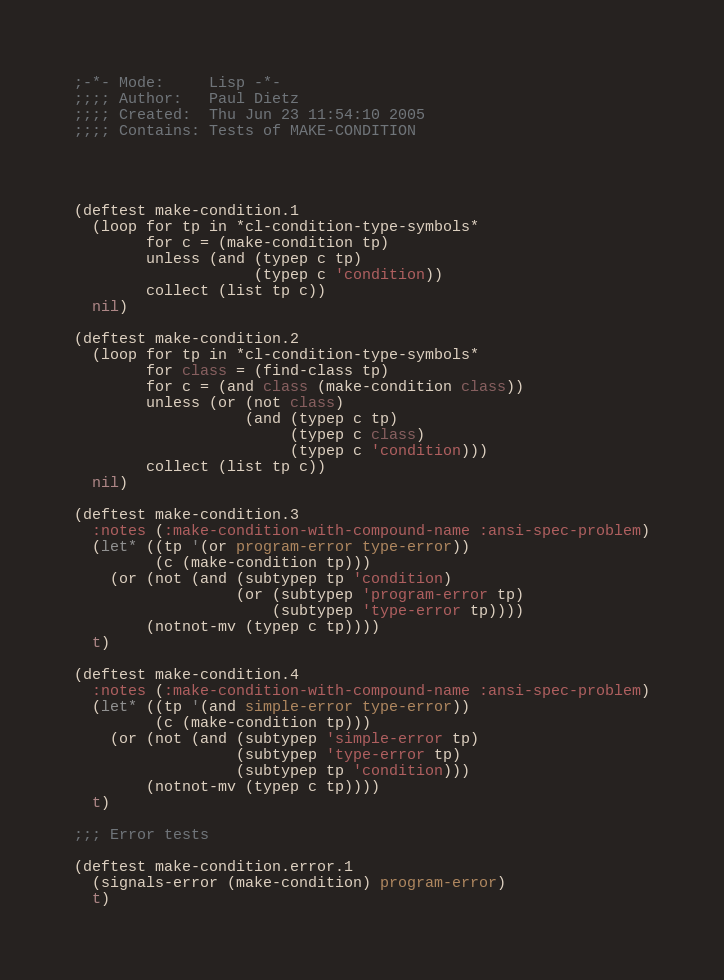<code> <loc_0><loc_0><loc_500><loc_500><_Lisp_>;-*- Mode:     Lisp -*-
;;;; Author:   Paul Dietz
;;;; Created:  Thu Jun 23 11:54:10 2005
;;;; Contains: Tests of MAKE-CONDITION




(deftest make-condition.1
  (loop for tp in *cl-condition-type-symbols*
        for c = (make-condition tp)
        unless (and (typep c tp)
                    (typep c 'condition))
        collect (list tp c))
  nil)

(deftest make-condition.2
  (loop for tp in *cl-condition-type-symbols*
        for class = (find-class tp)
        for c = (and class (make-condition class))
        unless (or (not class)
                   (and (typep c tp)
                        (typep c class)
                        (typep c 'condition)))
        collect (list tp c))
  nil)

(deftest make-condition.3
  :notes (:make-condition-with-compound-name :ansi-spec-problem)
  (let* ((tp '(or program-error type-error))
         (c (make-condition tp)))
    (or (not (and (subtypep tp 'condition)
                  (or (subtypep 'program-error tp)
                      (subtypep 'type-error tp))))
        (notnot-mv (typep c tp))))
  t)

(deftest make-condition.4
  :notes (:make-condition-with-compound-name :ansi-spec-problem)
  (let* ((tp '(and simple-error type-error))
         (c (make-condition tp)))
    (or (not (and (subtypep 'simple-error tp)
                  (subtypep 'type-error tp)
                  (subtypep tp 'condition)))
        (notnot-mv (typep c tp))))
  t)

;;; Error tests

(deftest make-condition.error.1
  (signals-error (make-condition) program-error)
  t)
</code> 